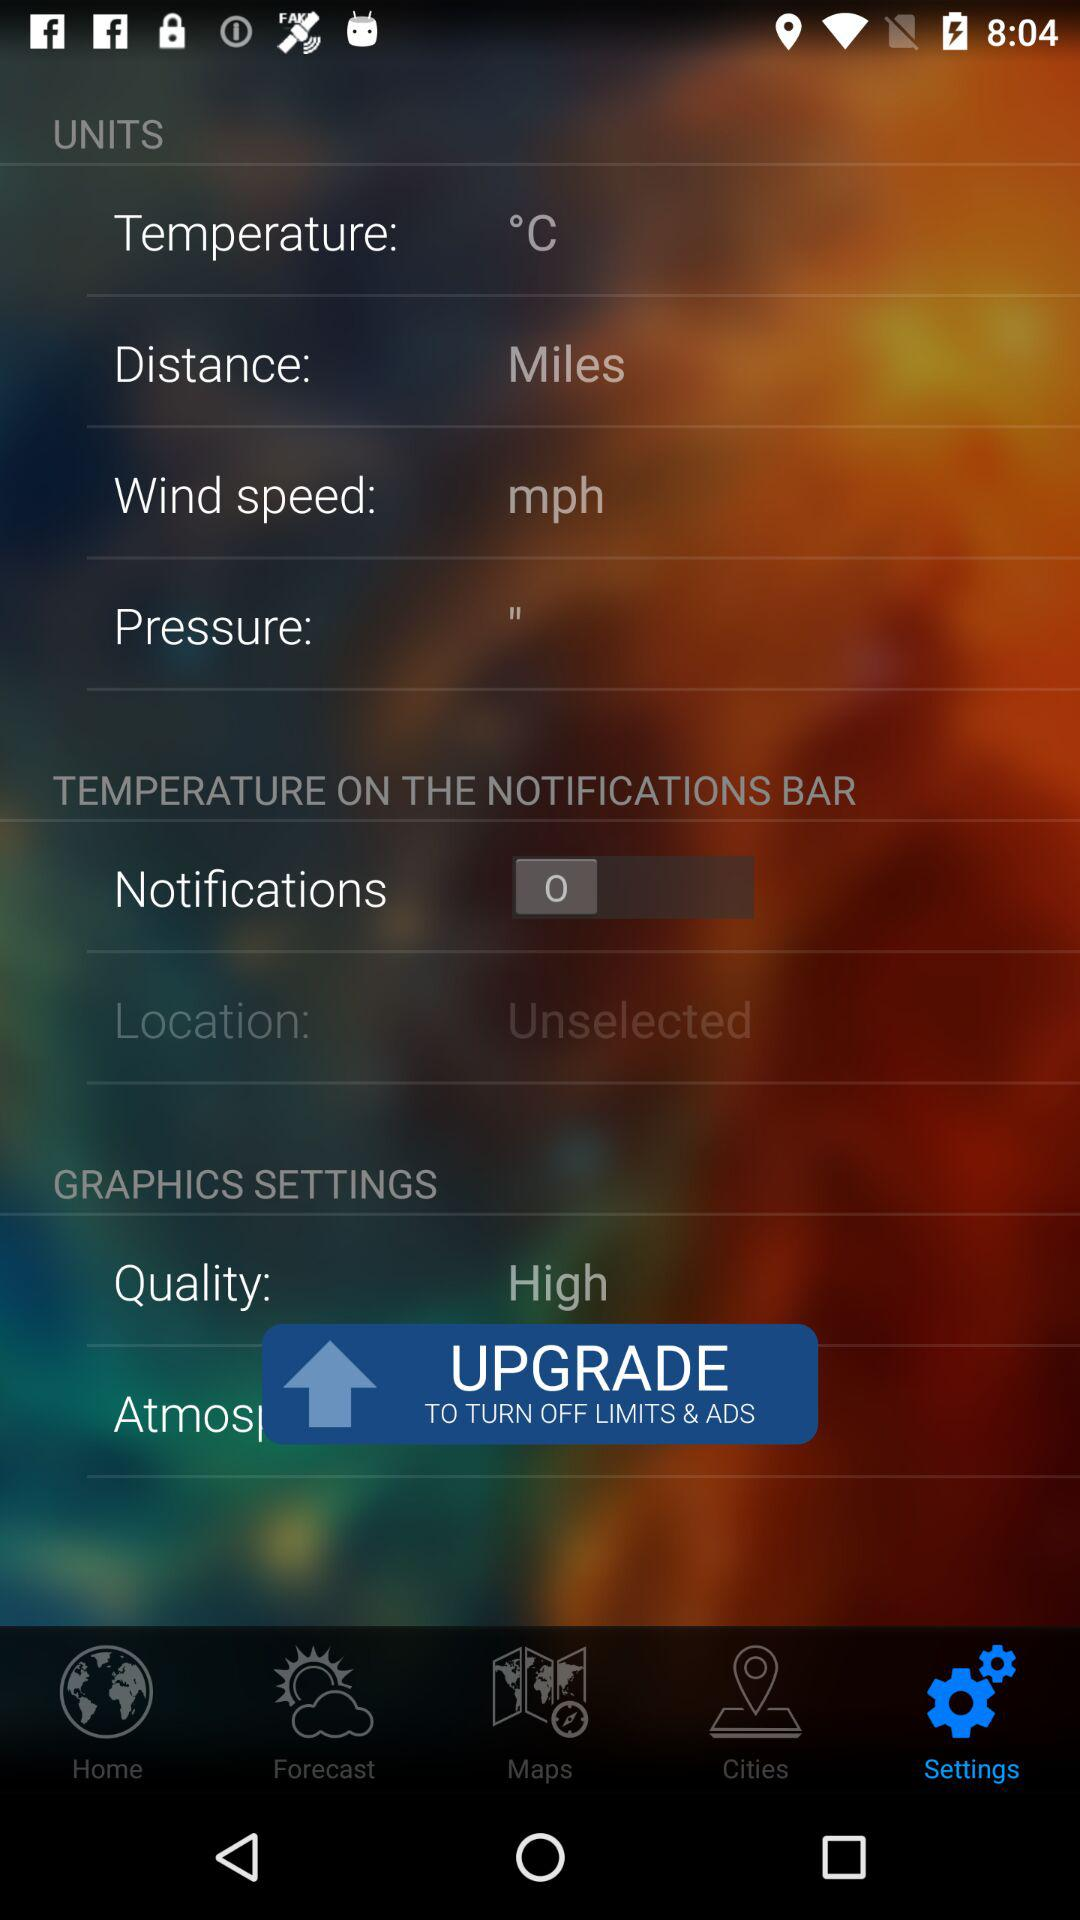What is the temperature on the notifications bar? The temperature on the notifications bar is 0. 